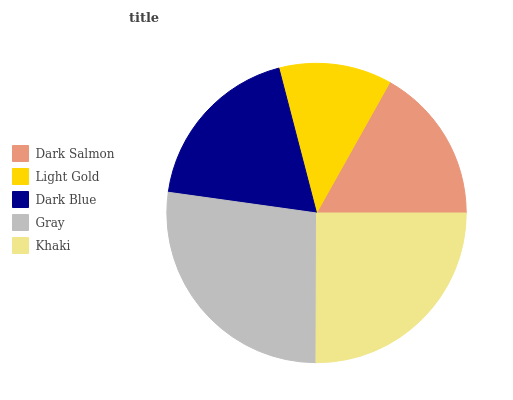Is Light Gold the minimum?
Answer yes or no. Yes. Is Gray the maximum?
Answer yes or no. Yes. Is Dark Blue the minimum?
Answer yes or no. No. Is Dark Blue the maximum?
Answer yes or no. No. Is Dark Blue greater than Light Gold?
Answer yes or no. Yes. Is Light Gold less than Dark Blue?
Answer yes or no. Yes. Is Light Gold greater than Dark Blue?
Answer yes or no. No. Is Dark Blue less than Light Gold?
Answer yes or no. No. Is Dark Blue the high median?
Answer yes or no. Yes. Is Dark Blue the low median?
Answer yes or no. Yes. Is Dark Salmon the high median?
Answer yes or no. No. Is Gray the low median?
Answer yes or no. No. 